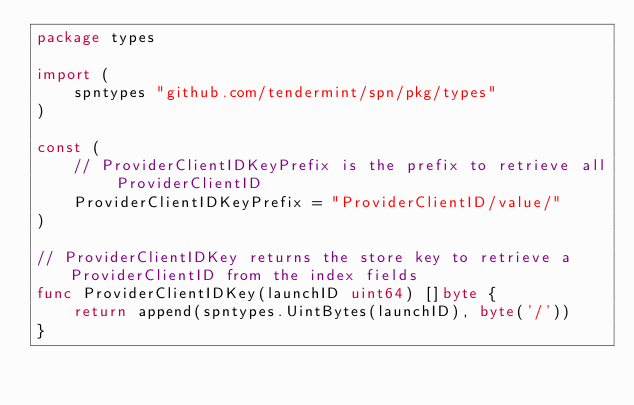<code> <loc_0><loc_0><loc_500><loc_500><_Go_>package types

import (
	spntypes "github.com/tendermint/spn/pkg/types"
)

const (
	// ProviderClientIDKeyPrefix is the prefix to retrieve all ProviderClientID
	ProviderClientIDKeyPrefix = "ProviderClientID/value/"
)

// ProviderClientIDKey returns the store key to retrieve a ProviderClientID from the index fields
func ProviderClientIDKey(launchID uint64) []byte {
	return append(spntypes.UintBytes(launchID), byte('/'))
}
</code> 